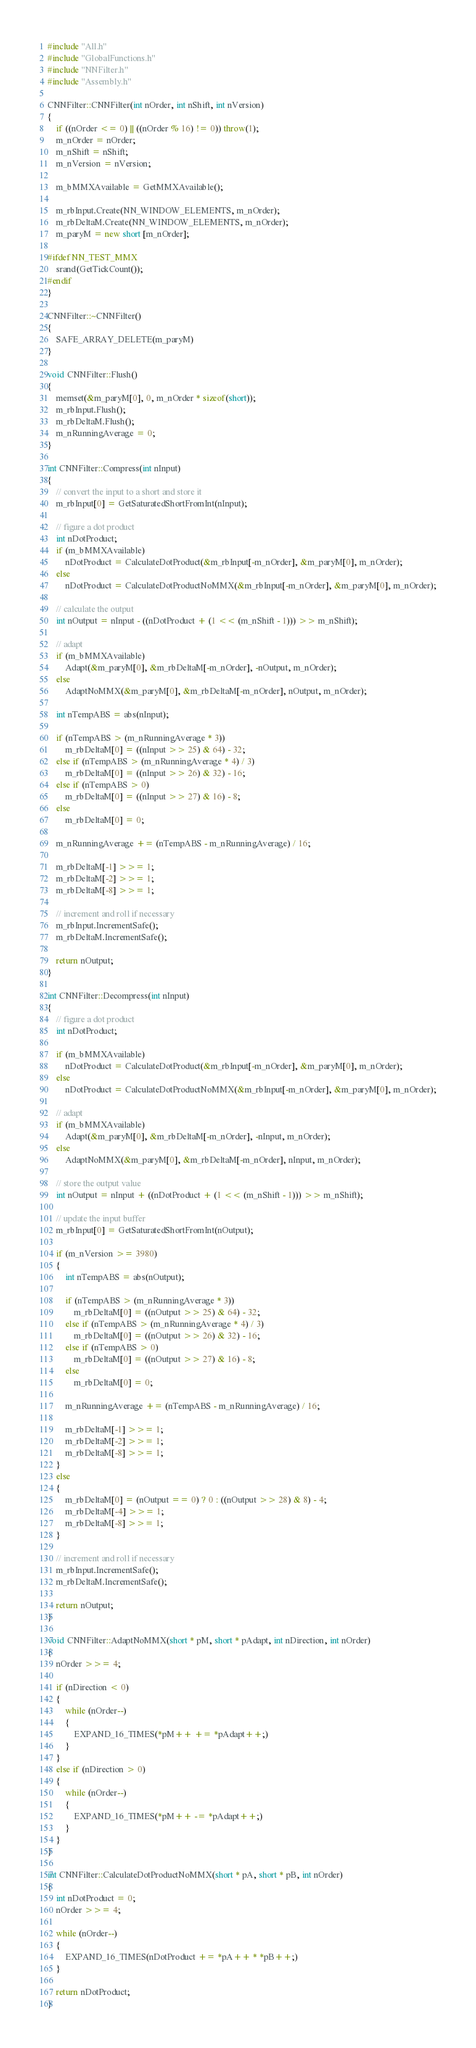Convert code to text. <code><loc_0><loc_0><loc_500><loc_500><_C++_>#include "All.h"
#include "GlobalFunctions.h"
#include "NNFilter.h"
#include "Assembly.h"

CNNFilter::CNNFilter(int nOrder, int nShift, int nVersion)
{
    if ((nOrder <= 0) || ((nOrder % 16) != 0)) throw(1);
    m_nOrder = nOrder;
    m_nShift = nShift;
    m_nVersion = nVersion;
    
    m_bMMXAvailable = GetMMXAvailable();
    
    m_rbInput.Create(NN_WINDOW_ELEMENTS, m_nOrder);
    m_rbDeltaM.Create(NN_WINDOW_ELEMENTS, m_nOrder);
    m_paryM = new short [m_nOrder];

#ifdef NN_TEST_MMX
    srand(GetTickCount());
#endif
}

CNNFilter::~CNNFilter()
{
    SAFE_ARRAY_DELETE(m_paryM)
}

void CNNFilter::Flush()
{
    memset(&m_paryM[0], 0, m_nOrder * sizeof(short));
    m_rbInput.Flush();
    m_rbDeltaM.Flush();
    m_nRunningAverage = 0;
}

int CNNFilter::Compress(int nInput)
{
    // convert the input to a short and store it
    m_rbInput[0] = GetSaturatedShortFromInt(nInput);

    // figure a dot product
    int nDotProduct;
    if (m_bMMXAvailable)
        nDotProduct = CalculateDotProduct(&m_rbInput[-m_nOrder], &m_paryM[0], m_nOrder);
    else
        nDotProduct = CalculateDotProductNoMMX(&m_rbInput[-m_nOrder], &m_paryM[0], m_nOrder);

    // calculate the output
    int nOutput = nInput - ((nDotProduct + (1 << (m_nShift - 1))) >> m_nShift);

    // adapt
    if (m_bMMXAvailable)
        Adapt(&m_paryM[0], &m_rbDeltaM[-m_nOrder], -nOutput, m_nOrder);
    else
        AdaptNoMMX(&m_paryM[0], &m_rbDeltaM[-m_nOrder], nOutput, m_nOrder);

    int nTempABS = abs(nInput);

    if (nTempABS > (m_nRunningAverage * 3))
        m_rbDeltaM[0] = ((nInput >> 25) & 64) - 32;
    else if (nTempABS > (m_nRunningAverage * 4) / 3)
        m_rbDeltaM[0] = ((nInput >> 26) & 32) - 16;
    else if (nTempABS > 0)
        m_rbDeltaM[0] = ((nInput >> 27) & 16) - 8;
    else
        m_rbDeltaM[0] = 0;

    m_nRunningAverage += (nTempABS - m_nRunningAverage) / 16;

    m_rbDeltaM[-1] >>= 1;
    m_rbDeltaM[-2] >>= 1;
    m_rbDeltaM[-8] >>= 1;
        
    // increment and roll if necessary
    m_rbInput.IncrementSafe();
    m_rbDeltaM.IncrementSafe();

    return nOutput;
}

int CNNFilter::Decompress(int nInput)
{
    // figure a dot product
    int nDotProduct;

    if (m_bMMXAvailable)
        nDotProduct = CalculateDotProduct(&m_rbInput[-m_nOrder], &m_paryM[0], m_nOrder);
    else
        nDotProduct = CalculateDotProductNoMMX(&m_rbInput[-m_nOrder], &m_paryM[0], m_nOrder);
    
    // adapt
    if (m_bMMXAvailable)
        Adapt(&m_paryM[0], &m_rbDeltaM[-m_nOrder], -nInput, m_nOrder);
    else
        AdaptNoMMX(&m_paryM[0], &m_rbDeltaM[-m_nOrder], nInput, m_nOrder);

    // store the output value
    int nOutput = nInput + ((nDotProduct + (1 << (m_nShift - 1))) >> m_nShift);

    // update the input buffer
    m_rbInput[0] = GetSaturatedShortFromInt(nOutput);

    if (m_nVersion >= 3980)
    {
        int nTempABS = abs(nOutput);

        if (nTempABS > (m_nRunningAverage * 3))
            m_rbDeltaM[0] = ((nOutput >> 25) & 64) - 32;
        else if (nTempABS > (m_nRunningAverage * 4) / 3)
            m_rbDeltaM[0] = ((nOutput >> 26) & 32) - 16;
        else if (nTempABS > 0)
            m_rbDeltaM[0] = ((nOutput >> 27) & 16) - 8;
        else
            m_rbDeltaM[0] = 0;

        m_nRunningAverage += (nTempABS - m_nRunningAverage) / 16;

        m_rbDeltaM[-1] >>= 1;
        m_rbDeltaM[-2] >>= 1;
        m_rbDeltaM[-8] >>= 1;
    }
    else
    {
        m_rbDeltaM[0] = (nOutput == 0) ? 0 : ((nOutput >> 28) & 8) - 4;
        m_rbDeltaM[-4] >>= 1;
        m_rbDeltaM[-8] >>= 1;
    }

    // increment and roll if necessary
    m_rbInput.IncrementSafe();
    m_rbDeltaM.IncrementSafe();
    
    return nOutput;
}

void CNNFilter::AdaptNoMMX(short * pM, short * pAdapt, int nDirection, int nOrder)
{
    nOrder >>= 4;

    if (nDirection < 0) 
    {    
        while (nOrder--)
        {
            EXPAND_16_TIMES(*pM++ += *pAdapt++;)
        }
    }
    else if (nDirection > 0)
    {
        while (nOrder--)
        {
            EXPAND_16_TIMES(*pM++ -= *pAdapt++;)
        }
    }
}

int CNNFilter::CalculateDotProductNoMMX(short * pA, short * pB, int nOrder)
{
    int nDotProduct = 0;
    nOrder >>= 4;

    while (nOrder--)
    {
        EXPAND_16_TIMES(nDotProduct += *pA++ * *pB++;)
    }
    
    return nDotProduct;
}
</code> 